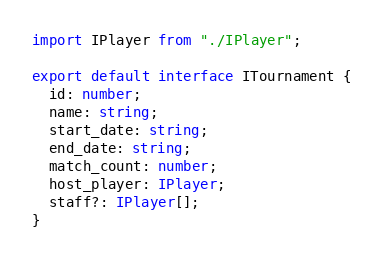<code> <loc_0><loc_0><loc_500><loc_500><_TypeScript_>import IPlayer from "./IPlayer";

export default interface ITournament {
  id: number;
  name: string;
  start_date: string;
  end_date: string;
  match_count: number;
  host_player: IPlayer;
  staff?: IPlayer[];
}
</code> 